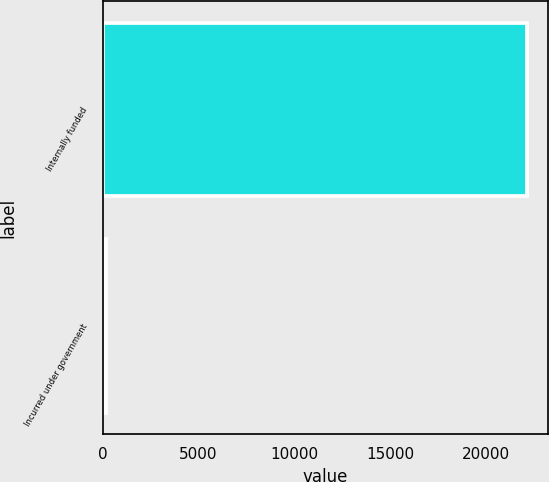<chart> <loc_0><loc_0><loc_500><loc_500><bar_chart><fcel>Internally funded<fcel>Incurred under government<nl><fcel>22123<fcel>169<nl></chart> 